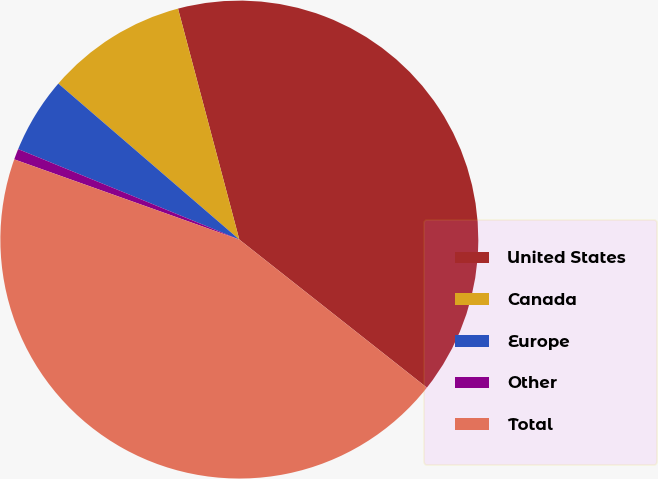Convert chart to OTSL. <chart><loc_0><loc_0><loc_500><loc_500><pie_chart><fcel>United States<fcel>Canada<fcel>Europe<fcel>Other<fcel>Total<nl><fcel>39.76%<fcel>9.55%<fcel>5.14%<fcel>0.73%<fcel>44.81%<nl></chart> 